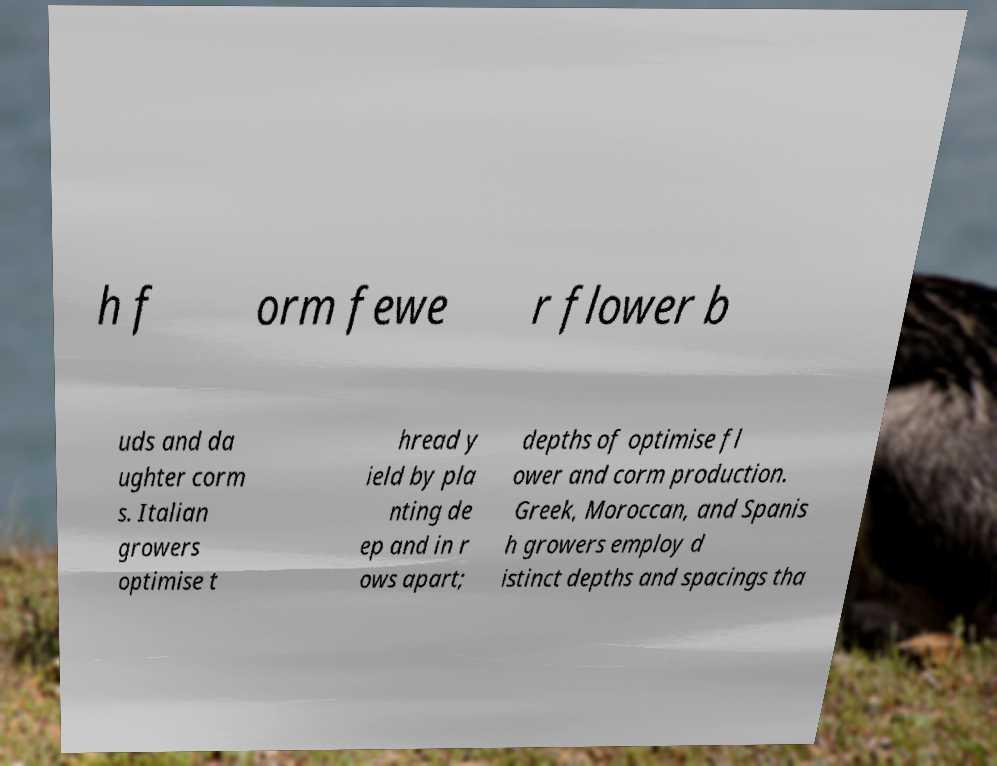Can you accurately transcribe the text from the provided image for me? h f orm fewe r flower b uds and da ughter corm s. Italian growers optimise t hread y ield by pla nting de ep and in r ows apart; depths of optimise fl ower and corm production. Greek, Moroccan, and Spanis h growers employ d istinct depths and spacings tha 